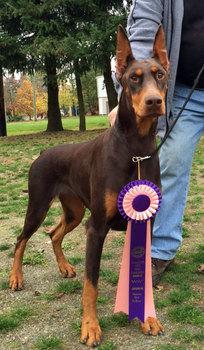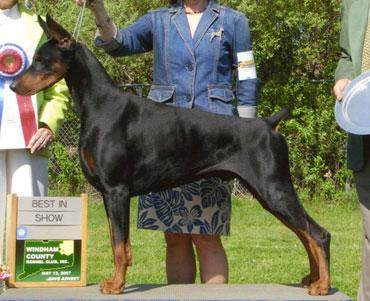The first image is the image on the left, the second image is the image on the right. Examine the images to the left and right. Is the description "There are three dogs sitting or laying on the grass." accurate? Answer yes or no. No. The first image is the image on the left, the second image is the image on the right. Considering the images on both sides, is "The right image contains a reclining doberman with erect ears." valid? Answer yes or no. No. 